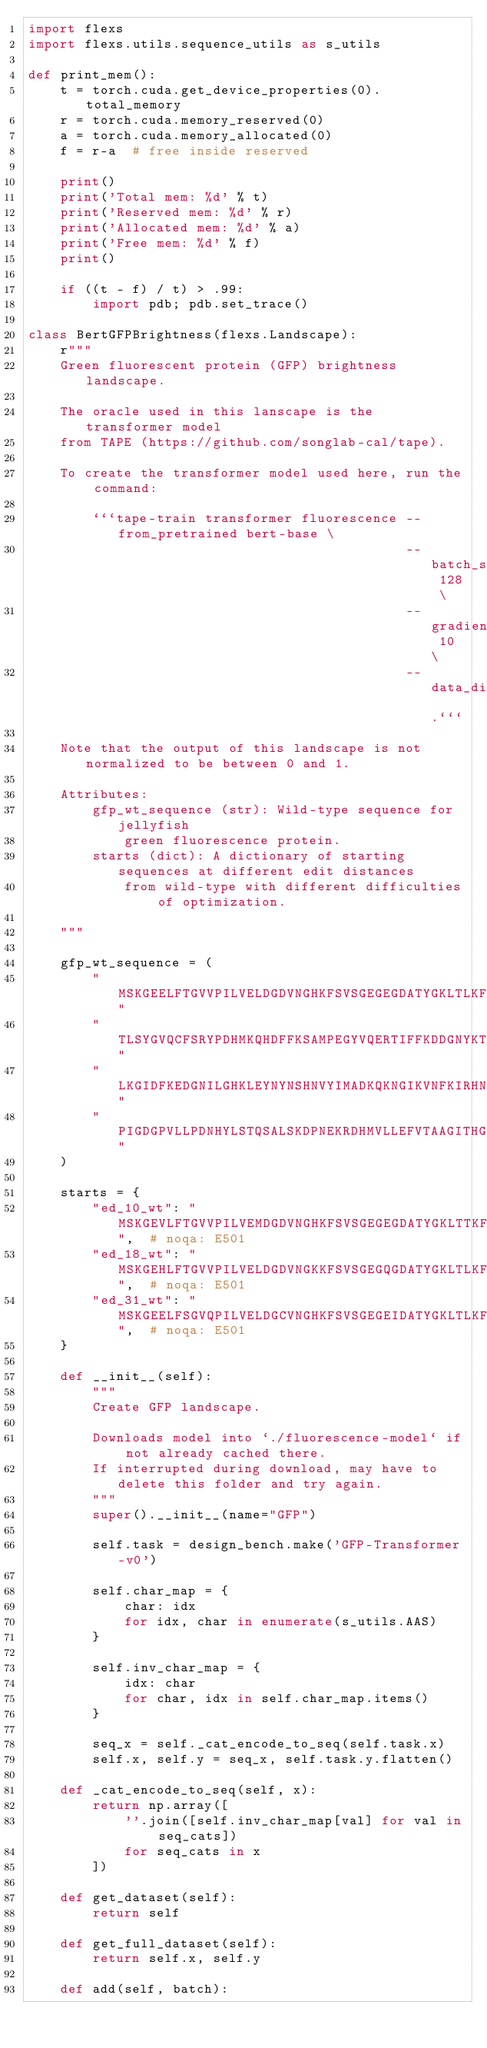<code> <loc_0><loc_0><loc_500><loc_500><_Python_>import flexs
import flexs.utils.sequence_utils as s_utils

def print_mem():
    t = torch.cuda.get_device_properties(0).total_memory
    r = torch.cuda.memory_reserved(0)
    a = torch.cuda.memory_allocated(0)
    f = r-a  # free inside reserved

    print()
    print('Total mem: %d' % t)
    print('Reserved mem: %d' % r)
    print('Allocated mem: %d' % a)
    print('Free mem: %d' % f)
    print()

    if ((t - f) / t) > .99:
        import pdb; pdb.set_trace()

class BertGFPBrightness(flexs.Landscape):
    r"""
    Green fluorescent protein (GFP) brightness landscape.

    The oracle used in this lanscape is the transformer model
    from TAPE (https://github.com/songlab-cal/tape).

    To create the transformer model used here, run the command:

        ```tape-train transformer fluorescence --from_pretrained bert-base \
                                               --batch_size 128 \
                                               --gradient_accumulation_steps 10 \
                                               --data_dir .```

    Note that the output of this landscape is not normalized to be between 0 and 1.

    Attributes:
        gfp_wt_sequence (str): Wild-type sequence for jellyfish
            green fluorescence protein.
        starts (dict): A dictionary of starting sequences at different edit distances
            from wild-type with different difficulties of optimization.

    """

    gfp_wt_sequence = (
        "MSKGEELFTGVVPILVELDGDVNGHKFSVSGEGEGDATYGKLTLKFICTTGKLPVPWPTLVT"
        "TLSYGVQCFSRYPDHMKQHDFFKSAMPEGYVQERTIFFKDDGNYKTRAEVKFEGDTLVNRIE"
        "LKGIDFKEDGNILGHKLEYNYNSHNVYIMADKQKNGIKVNFKIRHNIEDGSVQLADHYQQNT"
        "PIGDGPVLLPDNHYLSTQSALSKDPNEKRDHMVLLEFVTAAGITHGMDELYK"
    )

    starts = {
        "ed_10_wt": "MSKGEVLFTGVVPILVEMDGDVNGHKFSVSGEGEGDATYGKLTTKFTCTTGKLPVPWPTKVTTLSYRVQCFSRYPDVMKQHDFFKSAMPEGYVQERTIFFKDDGNYKTRAEVQFEGDTLVNRIELKGIDFKEDGNILGHKLEYNYNSHNVYIMADKQKNGIKVNFKIRHNIEDGSVQLADHYQQNTPIGDGPVLLPDNHYLSTQSALSKDPNIKRDCMVLLEFVTAAGITHGMDELY",  # noqa: E501
        "ed_18_wt": "MSKGEHLFTGVVPILVELDGDVNGKKFSVSGEGQGDATYGKLTLKFICTTAKVHVPWCTLVTTLSYGVQCFSRYPDHMKQHDFFKGAMPEGYVQERTIFFKDIGNYKLRAEVKFEGDTLVNRIELKGIDFKEDGNIHGHKLEYNYNSQNVYIMASKQKNGIKVNFKIRLNIEDGSVQLAEHYQVNTPIGDFPVLLPDNHKLSAQSADSKDPNEKRDHMHLLEFVTAVGITHGMDELYK",  # noqa: E501
        "ed_31_wt": "MSKGEELFSGVQPILVELDGCVNGHKFSVSGEGEIDATYGKLTLKFICTTWKLPMPWPCLVTFGSYGVQCFSRYRDHPKQHDFFKSAVPEGYVQERTIFMKDDLLYKTRAEVKFEGLTLVNRIELKGKDFKEDGNILGHKLEYNYNSHCVYPMADWNKNWIKVNSKIRLPIEDGSVILADHYQQNTPIGDQPVLLPENHYLSTQSALSKDPEEKGDLMVLLEFVTAAGITHGMDELYK",  # noqa: E501
    }

    def __init__(self):
        """
        Create GFP landscape.

        Downloads model into `./fluorescence-model` if not already cached there.
        If interrupted during download, may have to delete this folder and try again.
        """
        super().__init__(name="GFP")

        self.task = design_bench.make('GFP-Transformer-v0')

        self.char_map = {
            char: idx
            for idx, char in enumerate(s_utils.AAS)
        }

        self.inv_char_map = {
            idx: char
            for char, idx in self.char_map.items()
        }

        seq_x = self._cat_encode_to_seq(self.task.x)
        self.x, self.y = seq_x, self.task.y.flatten()

    def _cat_encode_to_seq(self, x):
        return np.array([
            ''.join([self.inv_char_map[val] for val in seq_cats])
            for seq_cats in x
        ])

    def get_dataset(self):
        return self

    def get_full_dataset(self):
        return self.x, self.y

    def add(self, batch):</code> 